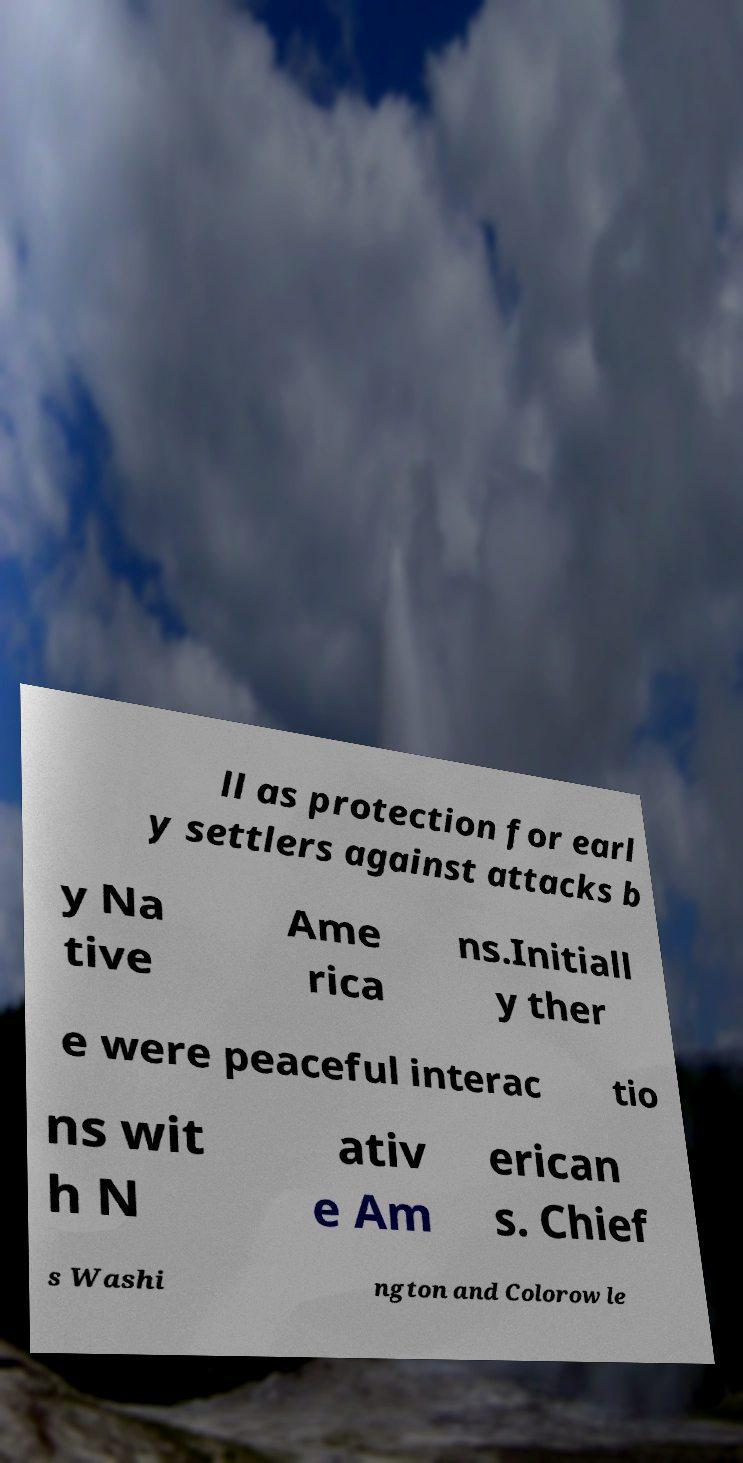Could you extract and type out the text from this image? ll as protection for earl y settlers against attacks b y Na tive Ame rica ns.Initiall y ther e were peaceful interac tio ns wit h N ativ e Am erican s. Chief s Washi ngton and Colorow le 